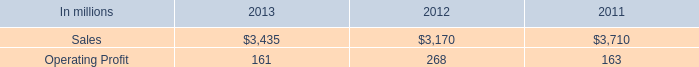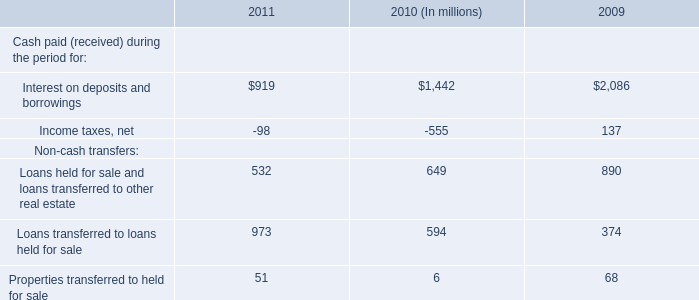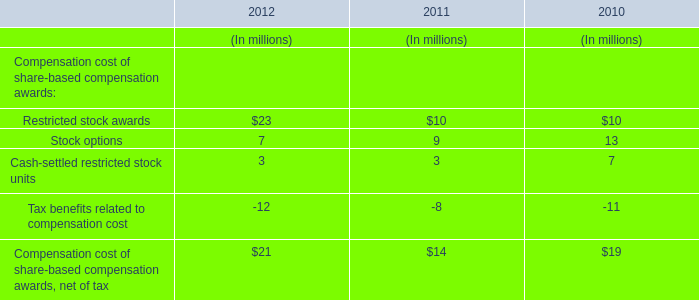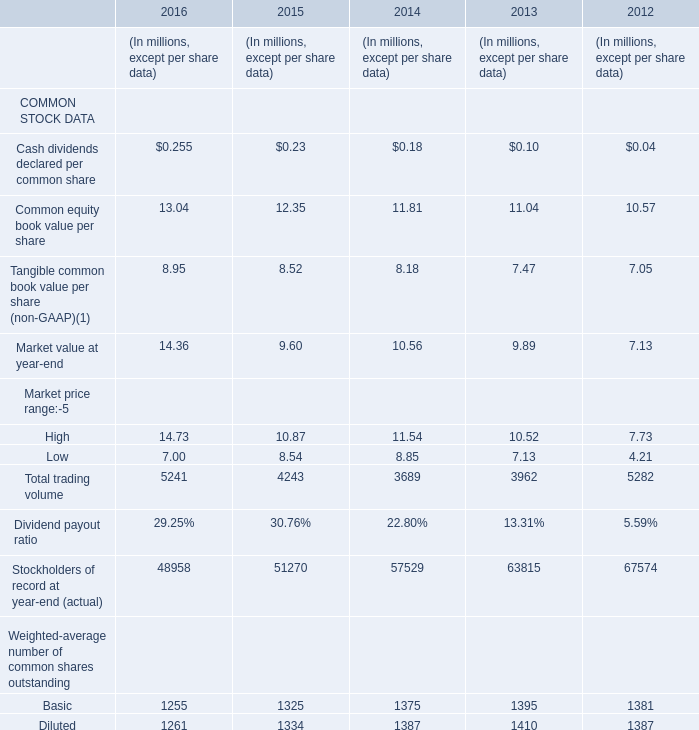When is Cash dividends declared per common share the largest? 
Answer: 2016. 